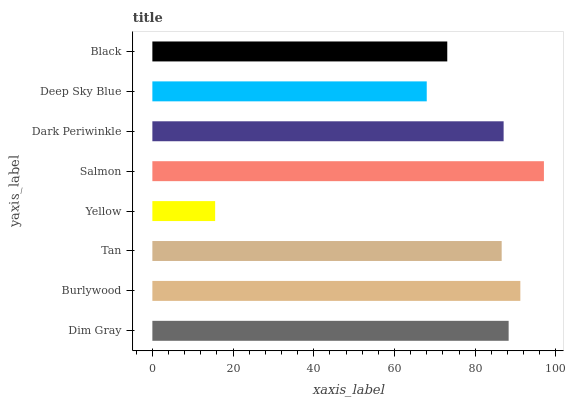Is Yellow the minimum?
Answer yes or no. Yes. Is Salmon the maximum?
Answer yes or no. Yes. Is Burlywood the minimum?
Answer yes or no. No. Is Burlywood the maximum?
Answer yes or no. No. Is Burlywood greater than Dim Gray?
Answer yes or no. Yes. Is Dim Gray less than Burlywood?
Answer yes or no. Yes. Is Dim Gray greater than Burlywood?
Answer yes or no. No. Is Burlywood less than Dim Gray?
Answer yes or no. No. Is Dark Periwinkle the high median?
Answer yes or no. Yes. Is Tan the low median?
Answer yes or no. Yes. Is Black the high median?
Answer yes or no. No. Is Dim Gray the low median?
Answer yes or no. No. 